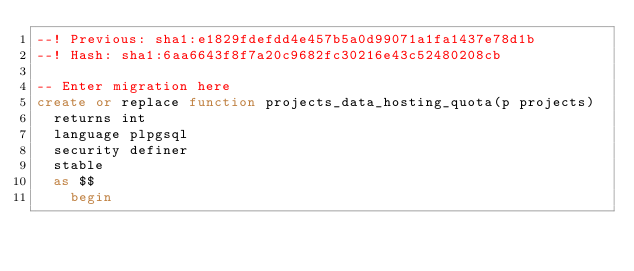<code> <loc_0><loc_0><loc_500><loc_500><_SQL_>--! Previous: sha1:e1829fdefdd4e457b5a0d99071a1fa1437e78d1b
--! Hash: sha1:6aa6643f8f7a20c9682fc30216e43c52480208cb

-- Enter migration here
create or replace function projects_data_hosting_quota(p projects)
  returns int
  language plpgsql
  security definer
  stable
  as $$
    begin</code> 